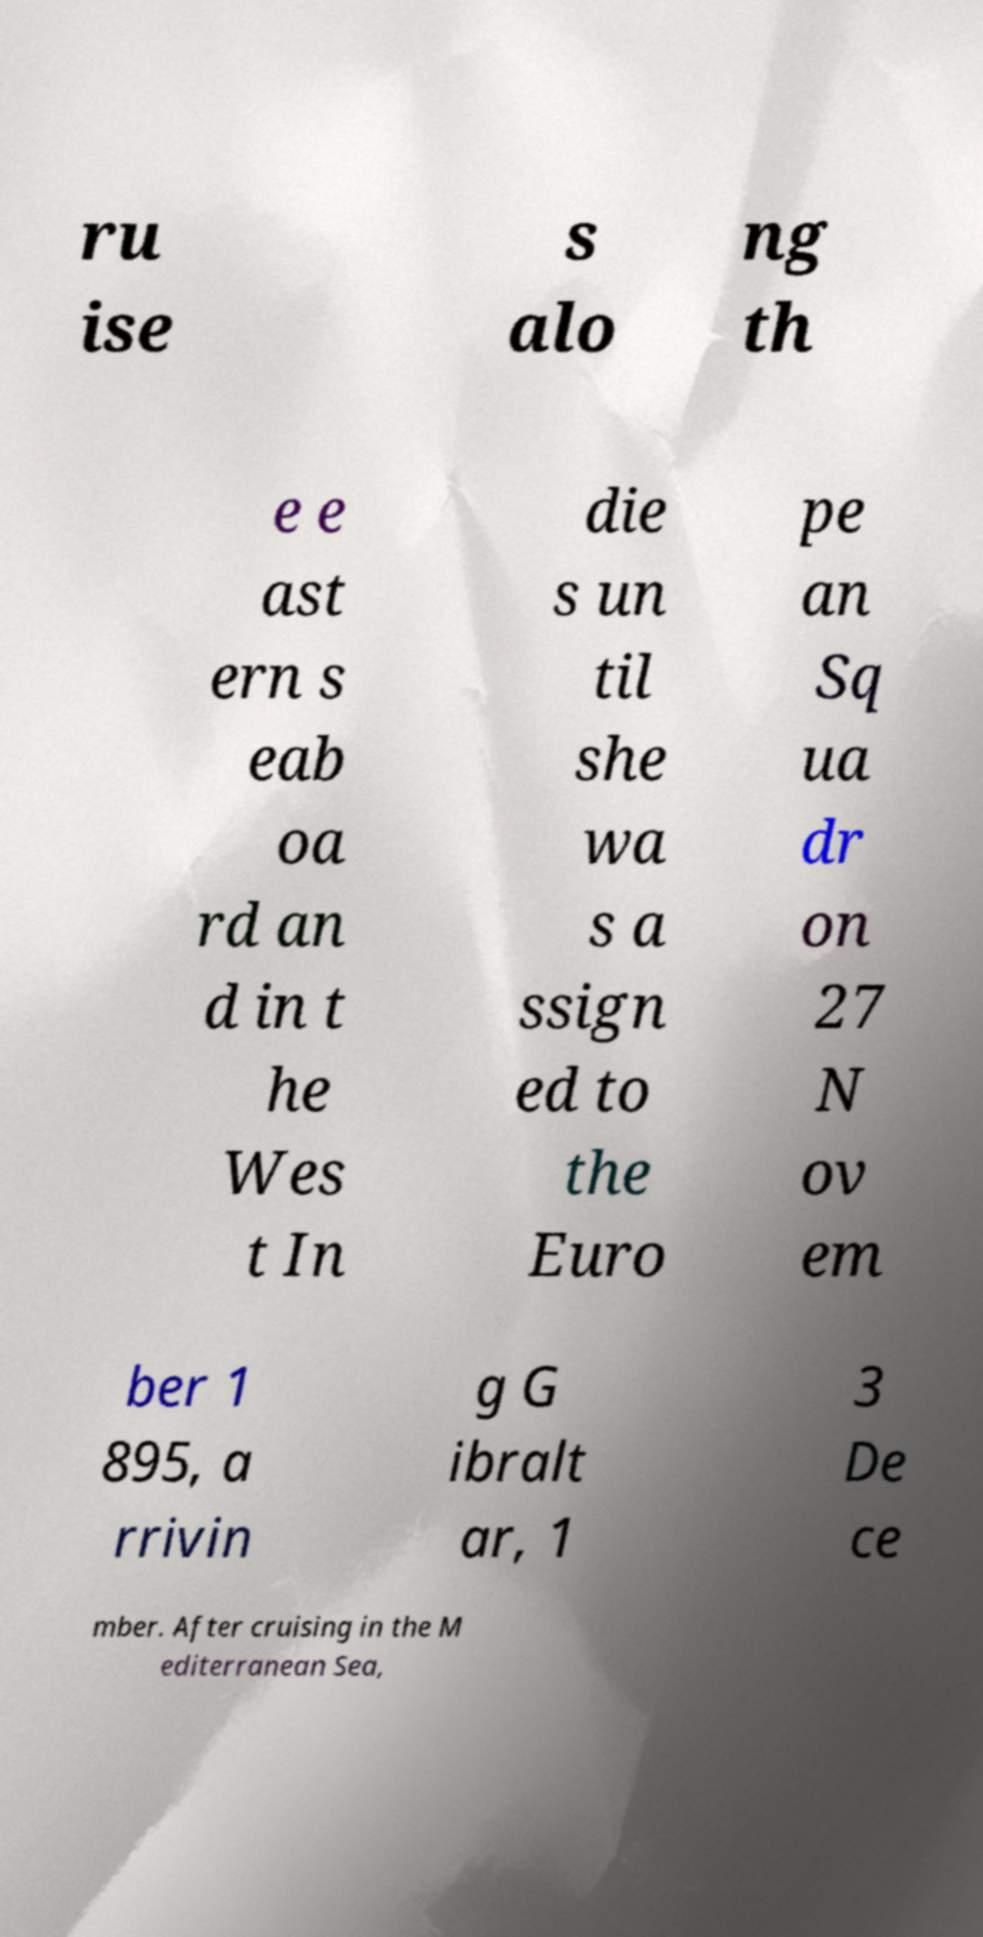Could you extract and type out the text from this image? ru ise s alo ng th e e ast ern s eab oa rd an d in t he Wes t In die s un til she wa s a ssign ed to the Euro pe an Sq ua dr on 27 N ov em ber 1 895, a rrivin g G ibralt ar, 1 3 De ce mber. After cruising in the M editerranean Sea, 